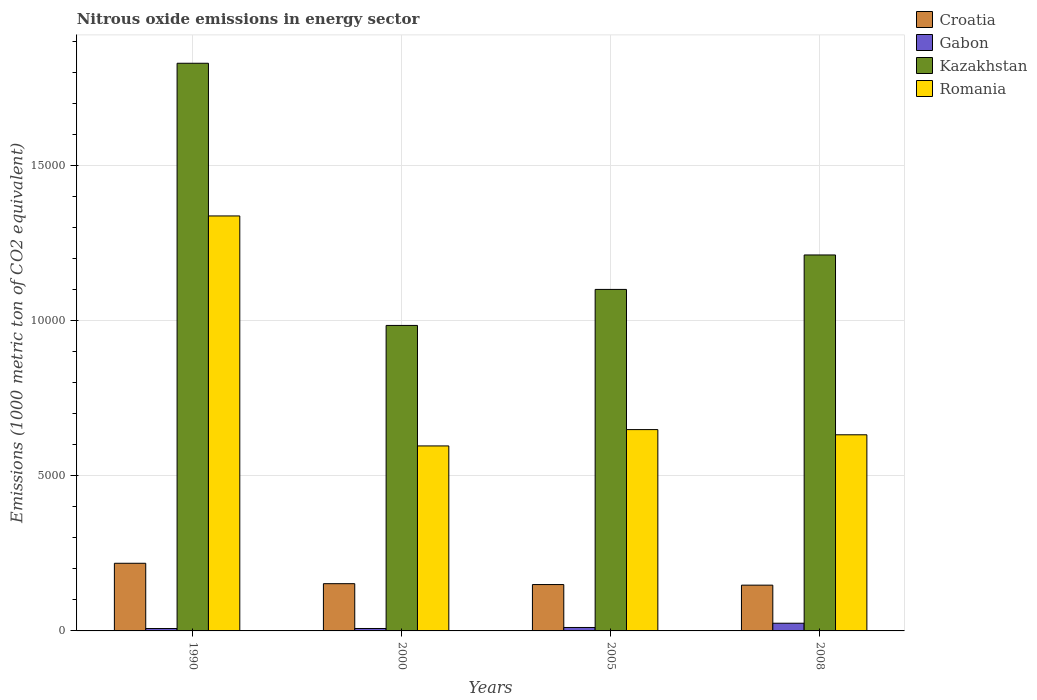How many different coloured bars are there?
Make the answer very short. 4. How many groups of bars are there?
Give a very brief answer. 4. Are the number of bars on each tick of the X-axis equal?
Keep it short and to the point. Yes. How many bars are there on the 1st tick from the left?
Give a very brief answer. 4. How many bars are there on the 4th tick from the right?
Your answer should be compact. 4. What is the amount of nitrous oxide emitted in Kazakhstan in 1990?
Your answer should be very brief. 1.83e+04. Across all years, what is the maximum amount of nitrous oxide emitted in Gabon?
Make the answer very short. 248.2. Across all years, what is the minimum amount of nitrous oxide emitted in Croatia?
Your response must be concise. 1474.8. In which year was the amount of nitrous oxide emitted in Croatia maximum?
Provide a short and direct response. 1990. In which year was the amount of nitrous oxide emitted in Romania minimum?
Your answer should be compact. 2000. What is the total amount of nitrous oxide emitted in Gabon in the graph?
Your answer should be compact. 514.7. What is the difference between the amount of nitrous oxide emitted in Romania in 1990 and that in 2008?
Provide a short and direct response. 7052.2. What is the difference between the amount of nitrous oxide emitted in Kazakhstan in 2000 and the amount of nitrous oxide emitted in Gabon in 1990?
Make the answer very short. 9766.9. What is the average amount of nitrous oxide emitted in Romania per year?
Offer a very short reply. 8035.23. In the year 2000, what is the difference between the amount of nitrous oxide emitted in Romania and amount of nitrous oxide emitted in Gabon?
Make the answer very short. 5882.9. In how many years, is the amount of nitrous oxide emitted in Croatia greater than 1000 1000 metric ton?
Keep it short and to the point. 4. What is the ratio of the amount of nitrous oxide emitted in Croatia in 1990 to that in 2005?
Your answer should be very brief. 1.46. What is the difference between the highest and the second highest amount of nitrous oxide emitted in Kazakhstan?
Provide a succinct answer. 6177.4. What is the difference between the highest and the lowest amount of nitrous oxide emitted in Romania?
Give a very brief answer. 7411.1. Is it the case that in every year, the sum of the amount of nitrous oxide emitted in Croatia and amount of nitrous oxide emitted in Romania is greater than the sum of amount of nitrous oxide emitted in Gabon and amount of nitrous oxide emitted in Kazakhstan?
Keep it short and to the point. Yes. What does the 4th bar from the left in 2008 represents?
Give a very brief answer. Romania. What does the 3rd bar from the right in 2000 represents?
Provide a succinct answer. Gabon. Is it the case that in every year, the sum of the amount of nitrous oxide emitted in Romania and amount of nitrous oxide emitted in Gabon is greater than the amount of nitrous oxide emitted in Kazakhstan?
Keep it short and to the point. No. How many years are there in the graph?
Offer a terse response. 4. How many legend labels are there?
Keep it short and to the point. 4. How are the legend labels stacked?
Provide a short and direct response. Vertical. What is the title of the graph?
Your answer should be very brief. Nitrous oxide emissions in energy sector. Does "Equatorial Guinea" appear as one of the legend labels in the graph?
Provide a succinct answer. No. What is the label or title of the X-axis?
Your answer should be compact. Years. What is the label or title of the Y-axis?
Your answer should be very brief. Emissions (1000 metric ton of CO2 equivalent). What is the Emissions (1000 metric ton of CO2 equivalent) of Croatia in 1990?
Provide a succinct answer. 2179.7. What is the Emissions (1000 metric ton of CO2 equivalent) of Gabon in 1990?
Offer a very short reply. 77.4. What is the Emissions (1000 metric ton of CO2 equivalent) of Kazakhstan in 1990?
Make the answer very short. 1.83e+04. What is the Emissions (1000 metric ton of CO2 equivalent) of Romania in 1990?
Give a very brief answer. 1.34e+04. What is the Emissions (1000 metric ton of CO2 equivalent) of Croatia in 2000?
Make the answer very short. 1522.5. What is the Emissions (1000 metric ton of CO2 equivalent) in Gabon in 2000?
Ensure brevity in your answer.  78.3. What is the Emissions (1000 metric ton of CO2 equivalent) of Kazakhstan in 2000?
Make the answer very short. 9844.3. What is the Emissions (1000 metric ton of CO2 equivalent) of Romania in 2000?
Your response must be concise. 5961.2. What is the Emissions (1000 metric ton of CO2 equivalent) in Croatia in 2005?
Your answer should be very brief. 1494. What is the Emissions (1000 metric ton of CO2 equivalent) of Gabon in 2005?
Your answer should be compact. 110.8. What is the Emissions (1000 metric ton of CO2 equivalent) in Kazakhstan in 2005?
Provide a short and direct response. 1.10e+04. What is the Emissions (1000 metric ton of CO2 equivalent) in Romania in 2005?
Keep it short and to the point. 6487.3. What is the Emissions (1000 metric ton of CO2 equivalent) in Croatia in 2008?
Make the answer very short. 1474.8. What is the Emissions (1000 metric ton of CO2 equivalent) of Gabon in 2008?
Ensure brevity in your answer.  248.2. What is the Emissions (1000 metric ton of CO2 equivalent) of Kazakhstan in 2008?
Provide a short and direct response. 1.21e+04. What is the Emissions (1000 metric ton of CO2 equivalent) of Romania in 2008?
Keep it short and to the point. 6320.1. Across all years, what is the maximum Emissions (1000 metric ton of CO2 equivalent) of Croatia?
Your answer should be compact. 2179.7. Across all years, what is the maximum Emissions (1000 metric ton of CO2 equivalent) of Gabon?
Your answer should be compact. 248.2. Across all years, what is the maximum Emissions (1000 metric ton of CO2 equivalent) in Kazakhstan?
Make the answer very short. 1.83e+04. Across all years, what is the maximum Emissions (1000 metric ton of CO2 equivalent) of Romania?
Make the answer very short. 1.34e+04. Across all years, what is the minimum Emissions (1000 metric ton of CO2 equivalent) of Croatia?
Your answer should be compact. 1474.8. Across all years, what is the minimum Emissions (1000 metric ton of CO2 equivalent) of Gabon?
Provide a short and direct response. 77.4. Across all years, what is the minimum Emissions (1000 metric ton of CO2 equivalent) in Kazakhstan?
Your response must be concise. 9844.3. Across all years, what is the minimum Emissions (1000 metric ton of CO2 equivalent) of Romania?
Your answer should be very brief. 5961.2. What is the total Emissions (1000 metric ton of CO2 equivalent) in Croatia in the graph?
Give a very brief answer. 6671. What is the total Emissions (1000 metric ton of CO2 equivalent) in Gabon in the graph?
Offer a very short reply. 514.7. What is the total Emissions (1000 metric ton of CO2 equivalent) in Kazakhstan in the graph?
Give a very brief answer. 5.13e+04. What is the total Emissions (1000 metric ton of CO2 equivalent) of Romania in the graph?
Provide a succinct answer. 3.21e+04. What is the difference between the Emissions (1000 metric ton of CO2 equivalent) of Croatia in 1990 and that in 2000?
Offer a terse response. 657.2. What is the difference between the Emissions (1000 metric ton of CO2 equivalent) in Kazakhstan in 1990 and that in 2000?
Provide a short and direct response. 8448.2. What is the difference between the Emissions (1000 metric ton of CO2 equivalent) in Romania in 1990 and that in 2000?
Make the answer very short. 7411.1. What is the difference between the Emissions (1000 metric ton of CO2 equivalent) in Croatia in 1990 and that in 2005?
Provide a short and direct response. 685.7. What is the difference between the Emissions (1000 metric ton of CO2 equivalent) of Gabon in 1990 and that in 2005?
Offer a terse response. -33.4. What is the difference between the Emissions (1000 metric ton of CO2 equivalent) of Kazakhstan in 1990 and that in 2005?
Give a very brief answer. 7287.5. What is the difference between the Emissions (1000 metric ton of CO2 equivalent) in Romania in 1990 and that in 2005?
Your answer should be compact. 6885. What is the difference between the Emissions (1000 metric ton of CO2 equivalent) in Croatia in 1990 and that in 2008?
Make the answer very short. 704.9. What is the difference between the Emissions (1000 metric ton of CO2 equivalent) in Gabon in 1990 and that in 2008?
Your response must be concise. -170.8. What is the difference between the Emissions (1000 metric ton of CO2 equivalent) of Kazakhstan in 1990 and that in 2008?
Provide a succinct answer. 6177.4. What is the difference between the Emissions (1000 metric ton of CO2 equivalent) of Romania in 1990 and that in 2008?
Make the answer very short. 7052.2. What is the difference between the Emissions (1000 metric ton of CO2 equivalent) in Croatia in 2000 and that in 2005?
Offer a very short reply. 28.5. What is the difference between the Emissions (1000 metric ton of CO2 equivalent) of Gabon in 2000 and that in 2005?
Your answer should be compact. -32.5. What is the difference between the Emissions (1000 metric ton of CO2 equivalent) of Kazakhstan in 2000 and that in 2005?
Keep it short and to the point. -1160.7. What is the difference between the Emissions (1000 metric ton of CO2 equivalent) of Romania in 2000 and that in 2005?
Your response must be concise. -526.1. What is the difference between the Emissions (1000 metric ton of CO2 equivalent) in Croatia in 2000 and that in 2008?
Your answer should be compact. 47.7. What is the difference between the Emissions (1000 metric ton of CO2 equivalent) of Gabon in 2000 and that in 2008?
Your answer should be very brief. -169.9. What is the difference between the Emissions (1000 metric ton of CO2 equivalent) in Kazakhstan in 2000 and that in 2008?
Give a very brief answer. -2270.8. What is the difference between the Emissions (1000 metric ton of CO2 equivalent) in Romania in 2000 and that in 2008?
Provide a succinct answer. -358.9. What is the difference between the Emissions (1000 metric ton of CO2 equivalent) in Croatia in 2005 and that in 2008?
Your response must be concise. 19.2. What is the difference between the Emissions (1000 metric ton of CO2 equivalent) of Gabon in 2005 and that in 2008?
Ensure brevity in your answer.  -137.4. What is the difference between the Emissions (1000 metric ton of CO2 equivalent) of Kazakhstan in 2005 and that in 2008?
Offer a very short reply. -1110.1. What is the difference between the Emissions (1000 metric ton of CO2 equivalent) in Romania in 2005 and that in 2008?
Give a very brief answer. 167.2. What is the difference between the Emissions (1000 metric ton of CO2 equivalent) in Croatia in 1990 and the Emissions (1000 metric ton of CO2 equivalent) in Gabon in 2000?
Ensure brevity in your answer.  2101.4. What is the difference between the Emissions (1000 metric ton of CO2 equivalent) of Croatia in 1990 and the Emissions (1000 metric ton of CO2 equivalent) of Kazakhstan in 2000?
Offer a very short reply. -7664.6. What is the difference between the Emissions (1000 metric ton of CO2 equivalent) of Croatia in 1990 and the Emissions (1000 metric ton of CO2 equivalent) of Romania in 2000?
Provide a short and direct response. -3781.5. What is the difference between the Emissions (1000 metric ton of CO2 equivalent) of Gabon in 1990 and the Emissions (1000 metric ton of CO2 equivalent) of Kazakhstan in 2000?
Your answer should be compact. -9766.9. What is the difference between the Emissions (1000 metric ton of CO2 equivalent) in Gabon in 1990 and the Emissions (1000 metric ton of CO2 equivalent) in Romania in 2000?
Ensure brevity in your answer.  -5883.8. What is the difference between the Emissions (1000 metric ton of CO2 equivalent) in Kazakhstan in 1990 and the Emissions (1000 metric ton of CO2 equivalent) in Romania in 2000?
Your answer should be compact. 1.23e+04. What is the difference between the Emissions (1000 metric ton of CO2 equivalent) of Croatia in 1990 and the Emissions (1000 metric ton of CO2 equivalent) of Gabon in 2005?
Provide a succinct answer. 2068.9. What is the difference between the Emissions (1000 metric ton of CO2 equivalent) in Croatia in 1990 and the Emissions (1000 metric ton of CO2 equivalent) in Kazakhstan in 2005?
Offer a very short reply. -8825.3. What is the difference between the Emissions (1000 metric ton of CO2 equivalent) of Croatia in 1990 and the Emissions (1000 metric ton of CO2 equivalent) of Romania in 2005?
Offer a very short reply. -4307.6. What is the difference between the Emissions (1000 metric ton of CO2 equivalent) of Gabon in 1990 and the Emissions (1000 metric ton of CO2 equivalent) of Kazakhstan in 2005?
Make the answer very short. -1.09e+04. What is the difference between the Emissions (1000 metric ton of CO2 equivalent) in Gabon in 1990 and the Emissions (1000 metric ton of CO2 equivalent) in Romania in 2005?
Offer a very short reply. -6409.9. What is the difference between the Emissions (1000 metric ton of CO2 equivalent) of Kazakhstan in 1990 and the Emissions (1000 metric ton of CO2 equivalent) of Romania in 2005?
Keep it short and to the point. 1.18e+04. What is the difference between the Emissions (1000 metric ton of CO2 equivalent) in Croatia in 1990 and the Emissions (1000 metric ton of CO2 equivalent) in Gabon in 2008?
Give a very brief answer. 1931.5. What is the difference between the Emissions (1000 metric ton of CO2 equivalent) of Croatia in 1990 and the Emissions (1000 metric ton of CO2 equivalent) of Kazakhstan in 2008?
Your response must be concise. -9935.4. What is the difference between the Emissions (1000 metric ton of CO2 equivalent) in Croatia in 1990 and the Emissions (1000 metric ton of CO2 equivalent) in Romania in 2008?
Your response must be concise. -4140.4. What is the difference between the Emissions (1000 metric ton of CO2 equivalent) in Gabon in 1990 and the Emissions (1000 metric ton of CO2 equivalent) in Kazakhstan in 2008?
Your answer should be compact. -1.20e+04. What is the difference between the Emissions (1000 metric ton of CO2 equivalent) of Gabon in 1990 and the Emissions (1000 metric ton of CO2 equivalent) of Romania in 2008?
Your answer should be compact. -6242.7. What is the difference between the Emissions (1000 metric ton of CO2 equivalent) of Kazakhstan in 1990 and the Emissions (1000 metric ton of CO2 equivalent) of Romania in 2008?
Make the answer very short. 1.20e+04. What is the difference between the Emissions (1000 metric ton of CO2 equivalent) of Croatia in 2000 and the Emissions (1000 metric ton of CO2 equivalent) of Gabon in 2005?
Your answer should be compact. 1411.7. What is the difference between the Emissions (1000 metric ton of CO2 equivalent) of Croatia in 2000 and the Emissions (1000 metric ton of CO2 equivalent) of Kazakhstan in 2005?
Provide a succinct answer. -9482.5. What is the difference between the Emissions (1000 metric ton of CO2 equivalent) in Croatia in 2000 and the Emissions (1000 metric ton of CO2 equivalent) in Romania in 2005?
Provide a succinct answer. -4964.8. What is the difference between the Emissions (1000 metric ton of CO2 equivalent) in Gabon in 2000 and the Emissions (1000 metric ton of CO2 equivalent) in Kazakhstan in 2005?
Ensure brevity in your answer.  -1.09e+04. What is the difference between the Emissions (1000 metric ton of CO2 equivalent) of Gabon in 2000 and the Emissions (1000 metric ton of CO2 equivalent) of Romania in 2005?
Your response must be concise. -6409. What is the difference between the Emissions (1000 metric ton of CO2 equivalent) of Kazakhstan in 2000 and the Emissions (1000 metric ton of CO2 equivalent) of Romania in 2005?
Provide a short and direct response. 3357. What is the difference between the Emissions (1000 metric ton of CO2 equivalent) in Croatia in 2000 and the Emissions (1000 metric ton of CO2 equivalent) in Gabon in 2008?
Provide a short and direct response. 1274.3. What is the difference between the Emissions (1000 metric ton of CO2 equivalent) of Croatia in 2000 and the Emissions (1000 metric ton of CO2 equivalent) of Kazakhstan in 2008?
Your response must be concise. -1.06e+04. What is the difference between the Emissions (1000 metric ton of CO2 equivalent) in Croatia in 2000 and the Emissions (1000 metric ton of CO2 equivalent) in Romania in 2008?
Keep it short and to the point. -4797.6. What is the difference between the Emissions (1000 metric ton of CO2 equivalent) in Gabon in 2000 and the Emissions (1000 metric ton of CO2 equivalent) in Kazakhstan in 2008?
Ensure brevity in your answer.  -1.20e+04. What is the difference between the Emissions (1000 metric ton of CO2 equivalent) in Gabon in 2000 and the Emissions (1000 metric ton of CO2 equivalent) in Romania in 2008?
Ensure brevity in your answer.  -6241.8. What is the difference between the Emissions (1000 metric ton of CO2 equivalent) in Kazakhstan in 2000 and the Emissions (1000 metric ton of CO2 equivalent) in Romania in 2008?
Your response must be concise. 3524.2. What is the difference between the Emissions (1000 metric ton of CO2 equivalent) in Croatia in 2005 and the Emissions (1000 metric ton of CO2 equivalent) in Gabon in 2008?
Provide a short and direct response. 1245.8. What is the difference between the Emissions (1000 metric ton of CO2 equivalent) in Croatia in 2005 and the Emissions (1000 metric ton of CO2 equivalent) in Kazakhstan in 2008?
Offer a very short reply. -1.06e+04. What is the difference between the Emissions (1000 metric ton of CO2 equivalent) of Croatia in 2005 and the Emissions (1000 metric ton of CO2 equivalent) of Romania in 2008?
Offer a terse response. -4826.1. What is the difference between the Emissions (1000 metric ton of CO2 equivalent) in Gabon in 2005 and the Emissions (1000 metric ton of CO2 equivalent) in Kazakhstan in 2008?
Offer a very short reply. -1.20e+04. What is the difference between the Emissions (1000 metric ton of CO2 equivalent) of Gabon in 2005 and the Emissions (1000 metric ton of CO2 equivalent) of Romania in 2008?
Provide a succinct answer. -6209.3. What is the difference between the Emissions (1000 metric ton of CO2 equivalent) of Kazakhstan in 2005 and the Emissions (1000 metric ton of CO2 equivalent) of Romania in 2008?
Give a very brief answer. 4684.9. What is the average Emissions (1000 metric ton of CO2 equivalent) in Croatia per year?
Offer a terse response. 1667.75. What is the average Emissions (1000 metric ton of CO2 equivalent) in Gabon per year?
Provide a short and direct response. 128.68. What is the average Emissions (1000 metric ton of CO2 equivalent) of Kazakhstan per year?
Your answer should be compact. 1.28e+04. What is the average Emissions (1000 metric ton of CO2 equivalent) of Romania per year?
Offer a terse response. 8035.23. In the year 1990, what is the difference between the Emissions (1000 metric ton of CO2 equivalent) in Croatia and Emissions (1000 metric ton of CO2 equivalent) in Gabon?
Your response must be concise. 2102.3. In the year 1990, what is the difference between the Emissions (1000 metric ton of CO2 equivalent) of Croatia and Emissions (1000 metric ton of CO2 equivalent) of Kazakhstan?
Provide a succinct answer. -1.61e+04. In the year 1990, what is the difference between the Emissions (1000 metric ton of CO2 equivalent) in Croatia and Emissions (1000 metric ton of CO2 equivalent) in Romania?
Keep it short and to the point. -1.12e+04. In the year 1990, what is the difference between the Emissions (1000 metric ton of CO2 equivalent) of Gabon and Emissions (1000 metric ton of CO2 equivalent) of Kazakhstan?
Make the answer very short. -1.82e+04. In the year 1990, what is the difference between the Emissions (1000 metric ton of CO2 equivalent) of Gabon and Emissions (1000 metric ton of CO2 equivalent) of Romania?
Your response must be concise. -1.33e+04. In the year 1990, what is the difference between the Emissions (1000 metric ton of CO2 equivalent) in Kazakhstan and Emissions (1000 metric ton of CO2 equivalent) in Romania?
Your answer should be very brief. 4920.2. In the year 2000, what is the difference between the Emissions (1000 metric ton of CO2 equivalent) of Croatia and Emissions (1000 metric ton of CO2 equivalent) of Gabon?
Your response must be concise. 1444.2. In the year 2000, what is the difference between the Emissions (1000 metric ton of CO2 equivalent) in Croatia and Emissions (1000 metric ton of CO2 equivalent) in Kazakhstan?
Your answer should be compact. -8321.8. In the year 2000, what is the difference between the Emissions (1000 metric ton of CO2 equivalent) of Croatia and Emissions (1000 metric ton of CO2 equivalent) of Romania?
Offer a very short reply. -4438.7. In the year 2000, what is the difference between the Emissions (1000 metric ton of CO2 equivalent) of Gabon and Emissions (1000 metric ton of CO2 equivalent) of Kazakhstan?
Your response must be concise. -9766. In the year 2000, what is the difference between the Emissions (1000 metric ton of CO2 equivalent) of Gabon and Emissions (1000 metric ton of CO2 equivalent) of Romania?
Your answer should be compact. -5882.9. In the year 2000, what is the difference between the Emissions (1000 metric ton of CO2 equivalent) in Kazakhstan and Emissions (1000 metric ton of CO2 equivalent) in Romania?
Your answer should be very brief. 3883.1. In the year 2005, what is the difference between the Emissions (1000 metric ton of CO2 equivalent) of Croatia and Emissions (1000 metric ton of CO2 equivalent) of Gabon?
Provide a succinct answer. 1383.2. In the year 2005, what is the difference between the Emissions (1000 metric ton of CO2 equivalent) in Croatia and Emissions (1000 metric ton of CO2 equivalent) in Kazakhstan?
Your response must be concise. -9511. In the year 2005, what is the difference between the Emissions (1000 metric ton of CO2 equivalent) of Croatia and Emissions (1000 metric ton of CO2 equivalent) of Romania?
Your answer should be compact. -4993.3. In the year 2005, what is the difference between the Emissions (1000 metric ton of CO2 equivalent) of Gabon and Emissions (1000 metric ton of CO2 equivalent) of Kazakhstan?
Make the answer very short. -1.09e+04. In the year 2005, what is the difference between the Emissions (1000 metric ton of CO2 equivalent) in Gabon and Emissions (1000 metric ton of CO2 equivalent) in Romania?
Your response must be concise. -6376.5. In the year 2005, what is the difference between the Emissions (1000 metric ton of CO2 equivalent) of Kazakhstan and Emissions (1000 metric ton of CO2 equivalent) of Romania?
Offer a very short reply. 4517.7. In the year 2008, what is the difference between the Emissions (1000 metric ton of CO2 equivalent) of Croatia and Emissions (1000 metric ton of CO2 equivalent) of Gabon?
Ensure brevity in your answer.  1226.6. In the year 2008, what is the difference between the Emissions (1000 metric ton of CO2 equivalent) of Croatia and Emissions (1000 metric ton of CO2 equivalent) of Kazakhstan?
Offer a very short reply. -1.06e+04. In the year 2008, what is the difference between the Emissions (1000 metric ton of CO2 equivalent) of Croatia and Emissions (1000 metric ton of CO2 equivalent) of Romania?
Keep it short and to the point. -4845.3. In the year 2008, what is the difference between the Emissions (1000 metric ton of CO2 equivalent) of Gabon and Emissions (1000 metric ton of CO2 equivalent) of Kazakhstan?
Keep it short and to the point. -1.19e+04. In the year 2008, what is the difference between the Emissions (1000 metric ton of CO2 equivalent) in Gabon and Emissions (1000 metric ton of CO2 equivalent) in Romania?
Provide a short and direct response. -6071.9. In the year 2008, what is the difference between the Emissions (1000 metric ton of CO2 equivalent) in Kazakhstan and Emissions (1000 metric ton of CO2 equivalent) in Romania?
Offer a very short reply. 5795. What is the ratio of the Emissions (1000 metric ton of CO2 equivalent) in Croatia in 1990 to that in 2000?
Offer a very short reply. 1.43. What is the ratio of the Emissions (1000 metric ton of CO2 equivalent) in Gabon in 1990 to that in 2000?
Your answer should be very brief. 0.99. What is the ratio of the Emissions (1000 metric ton of CO2 equivalent) in Kazakhstan in 1990 to that in 2000?
Your answer should be very brief. 1.86. What is the ratio of the Emissions (1000 metric ton of CO2 equivalent) of Romania in 1990 to that in 2000?
Offer a terse response. 2.24. What is the ratio of the Emissions (1000 metric ton of CO2 equivalent) of Croatia in 1990 to that in 2005?
Make the answer very short. 1.46. What is the ratio of the Emissions (1000 metric ton of CO2 equivalent) in Gabon in 1990 to that in 2005?
Offer a terse response. 0.7. What is the ratio of the Emissions (1000 metric ton of CO2 equivalent) of Kazakhstan in 1990 to that in 2005?
Offer a very short reply. 1.66. What is the ratio of the Emissions (1000 metric ton of CO2 equivalent) in Romania in 1990 to that in 2005?
Ensure brevity in your answer.  2.06. What is the ratio of the Emissions (1000 metric ton of CO2 equivalent) in Croatia in 1990 to that in 2008?
Your answer should be very brief. 1.48. What is the ratio of the Emissions (1000 metric ton of CO2 equivalent) of Gabon in 1990 to that in 2008?
Offer a very short reply. 0.31. What is the ratio of the Emissions (1000 metric ton of CO2 equivalent) in Kazakhstan in 1990 to that in 2008?
Your answer should be compact. 1.51. What is the ratio of the Emissions (1000 metric ton of CO2 equivalent) of Romania in 1990 to that in 2008?
Make the answer very short. 2.12. What is the ratio of the Emissions (1000 metric ton of CO2 equivalent) in Croatia in 2000 to that in 2005?
Give a very brief answer. 1.02. What is the ratio of the Emissions (1000 metric ton of CO2 equivalent) of Gabon in 2000 to that in 2005?
Your answer should be compact. 0.71. What is the ratio of the Emissions (1000 metric ton of CO2 equivalent) in Kazakhstan in 2000 to that in 2005?
Your response must be concise. 0.89. What is the ratio of the Emissions (1000 metric ton of CO2 equivalent) of Romania in 2000 to that in 2005?
Offer a terse response. 0.92. What is the ratio of the Emissions (1000 metric ton of CO2 equivalent) in Croatia in 2000 to that in 2008?
Your response must be concise. 1.03. What is the ratio of the Emissions (1000 metric ton of CO2 equivalent) in Gabon in 2000 to that in 2008?
Your answer should be very brief. 0.32. What is the ratio of the Emissions (1000 metric ton of CO2 equivalent) in Kazakhstan in 2000 to that in 2008?
Keep it short and to the point. 0.81. What is the ratio of the Emissions (1000 metric ton of CO2 equivalent) in Romania in 2000 to that in 2008?
Your answer should be very brief. 0.94. What is the ratio of the Emissions (1000 metric ton of CO2 equivalent) in Gabon in 2005 to that in 2008?
Your answer should be very brief. 0.45. What is the ratio of the Emissions (1000 metric ton of CO2 equivalent) in Kazakhstan in 2005 to that in 2008?
Your answer should be very brief. 0.91. What is the ratio of the Emissions (1000 metric ton of CO2 equivalent) of Romania in 2005 to that in 2008?
Give a very brief answer. 1.03. What is the difference between the highest and the second highest Emissions (1000 metric ton of CO2 equivalent) of Croatia?
Offer a terse response. 657.2. What is the difference between the highest and the second highest Emissions (1000 metric ton of CO2 equivalent) in Gabon?
Make the answer very short. 137.4. What is the difference between the highest and the second highest Emissions (1000 metric ton of CO2 equivalent) of Kazakhstan?
Offer a terse response. 6177.4. What is the difference between the highest and the second highest Emissions (1000 metric ton of CO2 equivalent) in Romania?
Ensure brevity in your answer.  6885. What is the difference between the highest and the lowest Emissions (1000 metric ton of CO2 equivalent) in Croatia?
Provide a short and direct response. 704.9. What is the difference between the highest and the lowest Emissions (1000 metric ton of CO2 equivalent) in Gabon?
Provide a short and direct response. 170.8. What is the difference between the highest and the lowest Emissions (1000 metric ton of CO2 equivalent) in Kazakhstan?
Your answer should be very brief. 8448.2. What is the difference between the highest and the lowest Emissions (1000 metric ton of CO2 equivalent) in Romania?
Offer a terse response. 7411.1. 